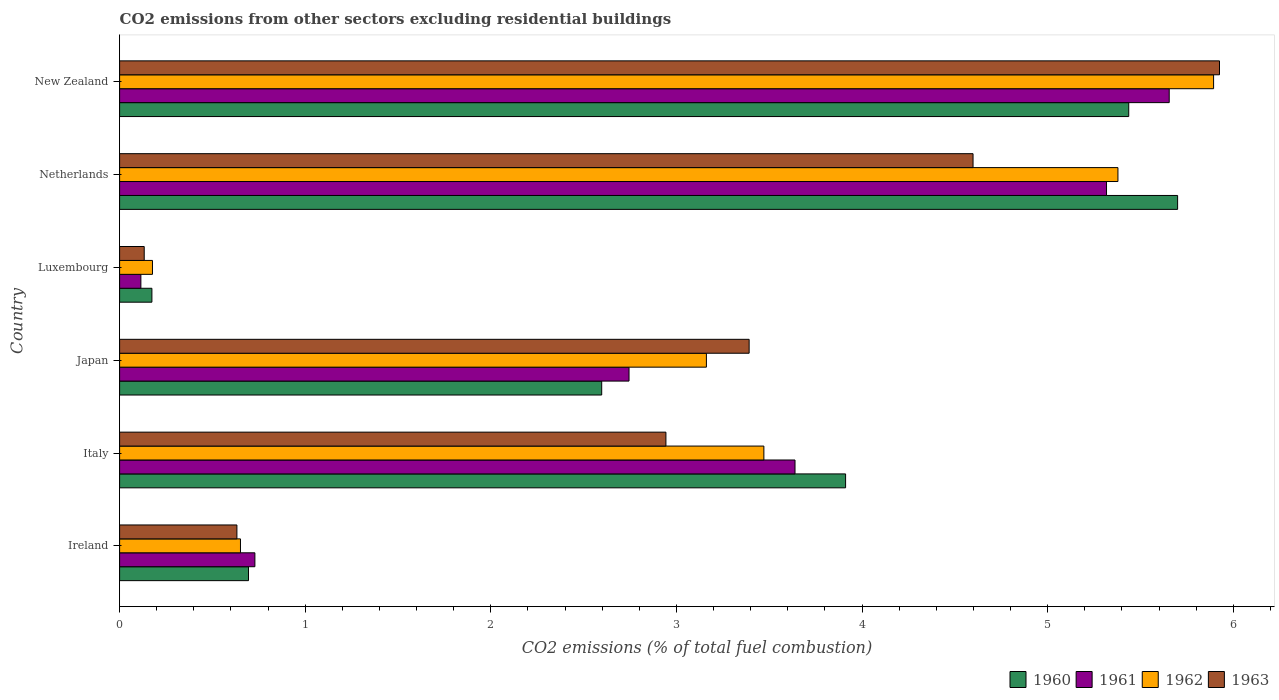How many different coloured bars are there?
Ensure brevity in your answer.  4. How many groups of bars are there?
Keep it short and to the point. 6. Are the number of bars per tick equal to the number of legend labels?
Provide a short and direct response. Yes. How many bars are there on the 1st tick from the top?
Ensure brevity in your answer.  4. What is the label of the 2nd group of bars from the top?
Keep it short and to the point. Netherlands. In how many cases, is the number of bars for a given country not equal to the number of legend labels?
Ensure brevity in your answer.  0. What is the total CO2 emitted in 1962 in Ireland?
Your answer should be compact. 0.65. Across all countries, what is the maximum total CO2 emitted in 1961?
Your response must be concise. 5.66. Across all countries, what is the minimum total CO2 emitted in 1960?
Offer a terse response. 0.17. In which country was the total CO2 emitted in 1960 minimum?
Your answer should be very brief. Luxembourg. What is the total total CO2 emitted in 1963 in the graph?
Offer a terse response. 17.62. What is the difference between the total CO2 emitted in 1962 in Italy and that in New Zealand?
Your response must be concise. -2.42. What is the difference between the total CO2 emitted in 1961 in Ireland and the total CO2 emitted in 1960 in New Zealand?
Your answer should be compact. -4.71. What is the average total CO2 emitted in 1963 per country?
Offer a terse response. 2.94. What is the difference between the total CO2 emitted in 1963 and total CO2 emitted in 1961 in Italy?
Provide a short and direct response. -0.7. In how many countries, is the total CO2 emitted in 1963 greater than 2.4 ?
Ensure brevity in your answer.  4. What is the ratio of the total CO2 emitted in 1961 in Japan to that in New Zealand?
Ensure brevity in your answer.  0.49. Is the total CO2 emitted in 1962 in Ireland less than that in Luxembourg?
Your response must be concise. No. Is the difference between the total CO2 emitted in 1963 in Italy and Luxembourg greater than the difference between the total CO2 emitted in 1961 in Italy and Luxembourg?
Your response must be concise. No. What is the difference between the highest and the second highest total CO2 emitted in 1961?
Your answer should be compact. 0.34. What is the difference between the highest and the lowest total CO2 emitted in 1962?
Your response must be concise. 5.72. Is it the case that in every country, the sum of the total CO2 emitted in 1962 and total CO2 emitted in 1961 is greater than the sum of total CO2 emitted in 1960 and total CO2 emitted in 1963?
Offer a terse response. No. What does the 2nd bar from the top in Ireland represents?
Offer a very short reply. 1962. Is it the case that in every country, the sum of the total CO2 emitted in 1960 and total CO2 emitted in 1962 is greater than the total CO2 emitted in 1963?
Your response must be concise. Yes. Are all the bars in the graph horizontal?
Ensure brevity in your answer.  Yes. What is the difference between two consecutive major ticks on the X-axis?
Provide a succinct answer. 1. Are the values on the major ticks of X-axis written in scientific E-notation?
Your answer should be compact. No. Does the graph contain grids?
Make the answer very short. No. Where does the legend appear in the graph?
Provide a short and direct response. Bottom right. How many legend labels are there?
Offer a very short reply. 4. How are the legend labels stacked?
Your answer should be compact. Horizontal. What is the title of the graph?
Offer a very short reply. CO2 emissions from other sectors excluding residential buildings. Does "1980" appear as one of the legend labels in the graph?
Make the answer very short. No. What is the label or title of the X-axis?
Offer a very short reply. CO2 emissions (% of total fuel combustion). What is the label or title of the Y-axis?
Offer a very short reply. Country. What is the CO2 emissions (% of total fuel combustion) of 1960 in Ireland?
Make the answer very short. 0.69. What is the CO2 emissions (% of total fuel combustion) in 1961 in Ireland?
Your answer should be very brief. 0.73. What is the CO2 emissions (% of total fuel combustion) in 1962 in Ireland?
Offer a terse response. 0.65. What is the CO2 emissions (% of total fuel combustion) of 1963 in Ireland?
Give a very brief answer. 0.63. What is the CO2 emissions (% of total fuel combustion) of 1960 in Italy?
Your response must be concise. 3.91. What is the CO2 emissions (% of total fuel combustion) in 1961 in Italy?
Your answer should be compact. 3.64. What is the CO2 emissions (% of total fuel combustion) in 1962 in Italy?
Your answer should be very brief. 3.47. What is the CO2 emissions (% of total fuel combustion) of 1963 in Italy?
Give a very brief answer. 2.94. What is the CO2 emissions (% of total fuel combustion) in 1960 in Japan?
Provide a short and direct response. 2.6. What is the CO2 emissions (% of total fuel combustion) of 1961 in Japan?
Your response must be concise. 2.74. What is the CO2 emissions (% of total fuel combustion) in 1962 in Japan?
Your answer should be very brief. 3.16. What is the CO2 emissions (% of total fuel combustion) in 1963 in Japan?
Ensure brevity in your answer.  3.39. What is the CO2 emissions (% of total fuel combustion) of 1960 in Luxembourg?
Make the answer very short. 0.17. What is the CO2 emissions (% of total fuel combustion) of 1961 in Luxembourg?
Your answer should be compact. 0.11. What is the CO2 emissions (% of total fuel combustion) of 1962 in Luxembourg?
Your response must be concise. 0.18. What is the CO2 emissions (% of total fuel combustion) in 1963 in Luxembourg?
Provide a short and direct response. 0.13. What is the CO2 emissions (% of total fuel combustion) in 1960 in Netherlands?
Your answer should be compact. 5.7. What is the CO2 emissions (% of total fuel combustion) of 1961 in Netherlands?
Make the answer very short. 5.32. What is the CO2 emissions (% of total fuel combustion) of 1962 in Netherlands?
Offer a very short reply. 5.38. What is the CO2 emissions (% of total fuel combustion) in 1963 in Netherlands?
Offer a terse response. 4.6. What is the CO2 emissions (% of total fuel combustion) in 1960 in New Zealand?
Offer a very short reply. 5.44. What is the CO2 emissions (% of total fuel combustion) in 1961 in New Zealand?
Give a very brief answer. 5.66. What is the CO2 emissions (% of total fuel combustion) of 1962 in New Zealand?
Offer a terse response. 5.89. What is the CO2 emissions (% of total fuel combustion) of 1963 in New Zealand?
Your response must be concise. 5.93. Across all countries, what is the maximum CO2 emissions (% of total fuel combustion) in 1960?
Ensure brevity in your answer.  5.7. Across all countries, what is the maximum CO2 emissions (% of total fuel combustion) in 1961?
Provide a succinct answer. 5.66. Across all countries, what is the maximum CO2 emissions (% of total fuel combustion) of 1962?
Offer a terse response. 5.89. Across all countries, what is the maximum CO2 emissions (% of total fuel combustion) in 1963?
Provide a succinct answer. 5.93. Across all countries, what is the minimum CO2 emissions (% of total fuel combustion) in 1960?
Your answer should be very brief. 0.17. Across all countries, what is the minimum CO2 emissions (% of total fuel combustion) in 1961?
Provide a short and direct response. 0.11. Across all countries, what is the minimum CO2 emissions (% of total fuel combustion) of 1962?
Provide a short and direct response. 0.18. Across all countries, what is the minimum CO2 emissions (% of total fuel combustion) of 1963?
Your answer should be very brief. 0.13. What is the total CO2 emissions (% of total fuel combustion) of 1960 in the graph?
Offer a terse response. 18.51. What is the total CO2 emissions (% of total fuel combustion) of 1961 in the graph?
Provide a succinct answer. 18.2. What is the total CO2 emissions (% of total fuel combustion) in 1962 in the graph?
Offer a very short reply. 18.73. What is the total CO2 emissions (% of total fuel combustion) of 1963 in the graph?
Your answer should be very brief. 17.62. What is the difference between the CO2 emissions (% of total fuel combustion) of 1960 in Ireland and that in Italy?
Your answer should be compact. -3.22. What is the difference between the CO2 emissions (% of total fuel combustion) of 1961 in Ireland and that in Italy?
Your response must be concise. -2.91. What is the difference between the CO2 emissions (% of total fuel combustion) in 1962 in Ireland and that in Italy?
Provide a succinct answer. -2.82. What is the difference between the CO2 emissions (% of total fuel combustion) in 1963 in Ireland and that in Italy?
Offer a very short reply. -2.31. What is the difference between the CO2 emissions (% of total fuel combustion) of 1960 in Ireland and that in Japan?
Make the answer very short. -1.9. What is the difference between the CO2 emissions (% of total fuel combustion) in 1961 in Ireland and that in Japan?
Provide a short and direct response. -2.02. What is the difference between the CO2 emissions (% of total fuel combustion) of 1962 in Ireland and that in Japan?
Keep it short and to the point. -2.51. What is the difference between the CO2 emissions (% of total fuel combustion) of 1963 in Ireland and that in Japan?
Keep it short and to the point. -2.76. What is the difference between the CO2 emissions (% of total fuel combustion) in 1960 in Ireland and that in Luxembourg?
Provide a short and direct response. 0.52. What is the difference between the CO2 emissions (% of total fuel combustion) in 1961 in Ireland and that in Luxembourg?
Offer a terse response. 0.61. What is the difference between the CO2 emissions (% of total fuel combustion) of 1962 in Ireland and that in Luxembourg?
Your answer should be very brief. 0.47. What is the difference between the CO2 emissions (% of total fuel combustion) in 1963 in Ireland and that in Luxembourg?
Provide a succinct answer. 0.5. What is the difference between the CO2 emissions (% of total fuel combustion) in 1960 in Ireland and that in Netherlands?
Your answer should be very brief. -5.01. What is the difference between the CO2 emissions (% of total fuel combustion) of 1961 in Ireland and that in Netherlands?
Your answer should be compact. -4.59. What is the difference between the CO2 emissions (% of total fuel combustion) in 1962 in Ireland and that in Netherlands?
Offer a terse response. -4.73. What is the difference between the CO2 emissions (% of total fuel combustion) in 1963 in Ireland and that in Netherlands?
Your response must be concise. -3.97. What is the difference between the CO2 emissions (% of total fuel combustion) in 1960 in Ireland and that in New Zealand?
Keep it short and to the point. -4.74. What is the difference between the CO2 emissions (% of total fuel combustion) of 1961 in Ireland and that in New Zealand?
Make the answer very short. -4.93. What is the difference between the CO2 emissions (% of total fuel combustion) of 1962 in Ireland and that in New Zealand?
Offer a very short reply. -5.24. What is the difference between the CO2 emissions (% of total fuel combustion) of 1963 in Ireland and that in New Zealand?
Provide a succinct answer. -5.29. What is the difference between the CO2 emissions (% of total fuel combustion) of 1960 in Italy and that in Japan?
Make the answer very short. 1.31. What is the difference between the CO2 emissions (% of total fuel combustion) in 1961 in Italy and that in Japan?
Provide a succinct answer. 0.89. What is the difference between the CO2 emissions (% of total fuel combustion) of 1962 in Italy and that in Japan?
Offer a very short reply. 0.31. What is the difference between the CO2 emissions (% of total fuel combustion) in 1963 in Italy and that in Japan?
Provide a short and direct response. -0.45. What is the difference between the CO2 emissions (% of total fuel combustion) in 1960 in Italy and that in Luxembourg?
Your answer should be very brief. 3.74. What is the difference between the CO2 emissions (% of total fuel combustion) in 1961 in Italy and that in Luxembourg?
Keep it short and to the point. 3.52. What is the difference between the CO2 emissions (% of total fuel combustion) in 1962 in Italy and that in Luxembourg?
Offer a very short reply. 3.29. What is the difference between the CO2 emissions (% of total fuel combustion) of 1963 in Italy and that in Luxembourg?
Ensure brevity in your answer.  2.81. What is the difference between the CO2 emissions (% of total fuel combustion) in 1960 in Italy and that in Netherlands?
Give a very brief answer. -1.79. What is the difference between the CO2 emissions (% of total fuel combustion) of 1961 in Italy and that in Netherlands?
Provide a succinct answer. -1.68. What is the difference between the CO2 emissions (% of total fuel combustion) in 1962 in Italy and that in Netherlands?
Give a very brief answer. -1.91. What is the difference between the CO2 emissions (% of total fuel combustion) in 1963 in Italy and that in Netherlands?
Your response must be concise. -1.65. What is the difference between the CO2 emissions (% of total fuel combustion) in 1960 in Italy and that in New Zealand?
Provide a short and direct response. -1.53. What is the difference between the CO2 emissions (% of total fuel combustion) of 1961 in Italy and that in New Zealand?
Your answer should be very brief. -2.02. What is the difference between the CO2 emissions (% of total fuel combustion) of 1962 in Italy and that in New Zealand?
Your answer should be compact. -2.42. What is the difference between the CO2 emissions (% of total fuel combustion) in 1963 in Italy and that in New Zealand?
Make the answer very short. -2.98. What is the difference between the CO2 emissions (% of total fuel combustion) of 1960 in Japan and that in Luxembourg?
Provide a succinct answer. 2.42. What is the difference between the CO2 emissions (% of total fuel combustion) in 1961 in Japan and that in Luxembourg?
Offer a terse response. 2.63. What is the difference between the CO2 emissions (% of total fuel combustion) in 1962 in Japan and that in Luxembourg?
Offer a very short reply. 2.98. What is the difference between the CO2 emissions (% of total fuel combustion) of 1963 in Japan and that in Luxembourg?
Give a very brief answer. 3.26. What is the difference between the CO2 emissions (% of total fuel combustion) of 1960 in Japan and that in Netherlands?
Keep it short and to the point. -3.1. What is the difference between the CO2 emissions (% of total fuel combustion) in 1961 in Japan and that in Netherlands?
Offer a terse response. -2.57. What is the difference between the CO2 emissions (% of total fuel combustion) of 1962 in Japan and that in Netherlands?
Provide a succinct answer. -2.22. What is the difference between the CO2 emissions (% of total fuel combustion) of 1963 in Japan and that in Netherlands?
Offer a very short reply. -1.21. What is the difference between the CO2 emissions (% of total fuel combustion) in 1960 in Japan and that in New Zealand?
Keep it short and to the point. -2.84. What is the difference between the CO2 emissions (% of total fuel combustion) of 1961 in Japan and that in New Zealand?
Provide a succinct answer. -2.91. What is the difference between the CO2 emissions (% of total fuel combustion) in 1962 in Japan and that in New Zealand?
Ensure brevity in your answer.  -2.73. What is the difference between the CO2 emissions (% of total fuel combustion) of 1963 in Japan and that in New Zealand?
Your response must be concise. -2.53. What is the difference between the CO2 emissions (% of total fuel combustion) of 1960 in Luxembourg and that in Netherlands?
Offer a very short reply. -5.53. What is the difference between the CO2 emissions (% of total fuel combustion) in 1961 in Luxembourg and that in Netherlands?
Your answer should be compact. -5.2. What is the difference between the CO2 emissions (% of total fuel combustion) in 1962 in Luxembourg and that in Netherlands?
Your answer should be very brief. -5.2. What is the difference between the CO2 emissions (% of total fuel combustion) of 1963 in Luxembourg and that in Netherlands?
Give a very brief answer. -4.47. What is the difference between the CO2 emissions (% of total fuel combustion) of 1960 in Luxembourg and that in New Zealand?
Your answer should be very brief. -5.26. What is the difference between the CO2 emissions (% of total fuel combustion) of 1961 in Luxembourg and that in New Zealand?
Ensure brevity in your answer.  -5.54. What is the difference between the CO2 emissions (% of total fuel combustion) of 1962 in Luxembourg and that in New Zealand?
Keep it short and to the point. -5.72. What is the difference between the CO2 emissions (% of total fuel combustion) in 1963 in Luxembourg and that in New Zealand?
Provide a succinct answer. -5.79. What is the difference between the CO2 emissions (% of total fuel combustion) of 1960 in Netherlands and that in New Zealand?
Provide a short and direct response. 0.26. What is the difference between the CO2 emissions (% of total fuel combustion) of 1961 in Netherlands and that in New Zealand?
Your answer should be very brief. -0.34. What is the difference between the CO2 emissions (% of total fuel combustion) of 1962 in Netherlands and that in New Zealand?
Ensure brevity in your answer.  -0.52. What is the difference between the CO2 emissions (% of total fuel combustion) in 1963 in Netherlands and that in New Zealand?
Offer a very short reply. -1.33. What is the difference between the CO2 emissions (% of total fuel combustion) of 1960 in Ireland and the CO2 emissions (% of total fuel combustion) of 1961 in Italy?
Give a very brief answer. -2.94. What is the difference between the CO2 emissions (% of total fuel combustion) of 1960 in Ireland and the CO2 emissions (% of total fuel combustion) of 1962 in Italy?
Provide a short and direct response. -2.78. What is the difference between the CO2 emissions (% of total fuel combustion) in 1960 in Ireland and the CO2 emissions (% of total fuel combustion) in 1963 in Italy?
Offer a terse response. -2.25. What is the difference between the CO2 emissions (% of total fuel combustion) in 1961 in Ireland and the CO2 emissions (% of total fuel combustion) in 1962 in Italy?
Your answer should be very brief. -2.74. What is the difference between the CO2 emissions (% of total fuel combustion) of 1961 in Ireland and the CO2 emissions (% of total fuel combustion) of 1963 in Italy?
Offer a very short reply. -2.21. What is the difference between the CO2 emissions (% of total fuel combustion) of 1962 in Ireland and the CO2 emissions (% of total fuel combustion) of 1963 in Italy?
Make the answer very short. -2.29. What is the difference between the CO2 emissions (% of total fuel combustion) in 1960 in Ireland and the CO2 emissions (% of total fuel combustion) in 1961 in Japan?
Give a very brief answer. -2.05. What is the difference between the CO2 emissions (% of total fuel combustion) of 1960 in Ireland and the CO2 emissions (% of total fuel combustion) of 1962 in Japan?
Provide a short and direct response. -2.47. What is the difference between the CO2 emissions (% of total fuel combustion) in 1960 in Ireland and the CO2 emissions (% of total fuel combustion) in 1963 in Japan?
Provide a succinct answer. -2.7. What is the difference between the CO2 emissions (% of total fuel combustion) in 1961 in Ireland and the CO2 emissions (% of total fuel combustion) in 1962 in Japan?
Provide a succinct answer. -2.43. What is the difference between the CO2 emissions (% of total fuel combustion) of 1961 in Ireland and the CO2 emissions (% of total fuel combustion) of 1963 in Japan?
Your answer should be very brief. -2.66. What is the difference between the CO2 emissions (% of total fuel combustion) in 1962 in Ireland and the CO2 emissions (% of total fuel combustion) in 1963 in Japan?
Make the answer very short. -2.74. What is the difference between the CO2 emissions (% of total fuel combustion) in 1960 in Ireland and the CO2 emissions (% of total fuel combustion) in 1961 in Luxembourg?
Provide a succinct answer. 0.58. What is the difference between the CO2 emissions (% of total fuel combustion) of 1960 in Ireland and the CO2 emissions (% of total fuel combustion) of 1962 in Luxembourg?
Provide a succinct answer. 0.52. What is the difference between the CO2 emissions (% of total fuel combustion) in 1960 in Ireland and the CO2 emissions (% of total fuel combustion) in 1963 in Luxembourg?
Your answer should be very brief. 0.56. What is the difference between the CO2 emissions (% of total fuel combustion) of 1961 in Ireland and the CO2 emissions (% of total fuel combustion) of 1962 in Luxembourg?
Your answer should be compact. 0.55. What is the difference between the CO2 emissions (% of total fuel combustion) of 1961 in Ireland and the CO2 emissions (% of total fuel combustion) of 1963 in Luxembourg?
Your answer should be very brief. 0.6. What is the difference between the CO2 emissions (% of total fuel combustion) in 1962 in Ireland and the CO2 emissions (% of total fuel combustion) in 1963 in Luxembourg?
Offer a very short reply. 0.52. What is the difference between the CO2 emissions (% of total fuel combustion) in 1960 in Ireland and the CO2 emissions (% of total fuel combustion) in 1961 in Netherlands?
Keep it short and to the point. -4.62. What is the difference between the CO2 emissions (% of total fuel combustion) in 1960 in Ireland and the CO2 emissions (% of total fuel combustion) in 1962 in Netherlands?
Ensure brevity in your answer.  -4.68. What is the difference between the CO2 emissions (% of total fuel combustion) of 1960 in Ireland and the CO2 emissions (% of total fuel combustion) of 1963 in Netherlands?
Your answer should be very brief. -3.9. What is the difference between the CO2 emissions (% of total fuel combustion) of 1961 in Ireland and the CO2 emissions (% of total fuel combustion) of 1962 in Netherlands?
Keep it short and to the point. -4.65. What is the difference between the CO2 emissions (% of total fuel combustion) of 1961 in Ireland and the CO2 emissions (% of total fuel combustion) of 1963 in Netherlands?
Provide a succinct answer. -3.87. What is the difference between the CO2 emissions (% of total fuel combustion) of 1962 in Ireland and the CO2 emissions (% of total fuel combustion) of 1963 in Netherlands?
Offer a very short reply. -3.95. What is the difference between the CO2 emissions (% of total fuel combustion) of 1960 in Ireland and the CO2 emissions (% of total fuel combustion) of 1961 in New Zealand?
Make the answer very short. -4.96. What is the difference between the CO2 emissions (% of total fuel combustion) in 1960 in Ireland and the CO2 emissions (% of total fuel combustion) in 1962 in New Zealand?
Give a very brief answer. -5.2. What is the difference between the CO2 emissions (% of total fuel combustion) of 1960 in Ireland and the CO2 emissions (% of total fuel combustion) of 1963 in New Zealand?
Ensure brevity in your answer.  -5.23. What is the difference between the CO2 emissions (% of total fuel combustion) in 1961 in Ireland and the CO2 emissions (% of total fuel combustion) in 1962 in New Zealand?
Offer a terse response. -5.17. What is the difference between the CO2 emissions (% of total fuel combustion) in 1961 in Ireland and the CO2 emissions (% of total fuel combustion) in 1963 in New Zealand?
Offer a very short reply. -5.2. What is the difference between the CO2 emissions (% of total fuel combustion) in 1962 in Ireland and the CO2 emissions (% of total fuel combustion) in 1963 in New Zealand?
Your response must be concise. -5.27. What is the difference between the CO2 emissions (% of total fuel combustion) of 1960 in Italy and the CO2 emissions (% of total fuel combustion) of 1961 in Japan?
Keep it short and to the point. 1.17. What is the difference between the CO2 emissions (% of total fuel combustion) in 1960 in Italy and the CO2 emissions (% of total fuel combustion) in 1962 in Japan?
Offer a very short reply. 0.75. What is the difference between the CO2 emissions (% of total fuel combustion) of 1960 in Italy and the CO2 emissions (% of total fuel combustion) of 1963 in Japan?
Provide a succinct answer. 0.52. What is the difference between the CO2 emissions (% of total fuel combustion) in 1961 in Italy and the CO2 emissions (% of total fuel combustion) in 1962 in Japan?
Ensure brevity in your answer.  0.48. What is the difference between the CO2 emissions (% of total fuel combustion) in 1961 in Italy and the CO2 emissions (% of total fuel combustion) in 1963 in Japan?
Offer a very short reply. 0.25. What is the difference between the CO2 emissions (% of total fuel combustion) in 1962 in Italy and the CO2 emissions (% of total fuel combustion) in 1963 in Japan?
Your answer should be very brief. 0.08. What is the difference between the CO2 emissions (% of total fuel combustion) in 1960 in Italy and the CO2 emissions (% of total fuel combustion) in 1961 in Luxembourg?
Offer a very short reply. 3.8. What is the difference between the CO2 emissions (% of total fuel combustion) in 1960 in Italy and the CO2 emissions (% of total fuel combustion) in 1962 in Luxembourg?
Offer a terse response. 3.73. What is the difference between the CO2 emissions (% of total fuel combustion) in 1960 in Italy and the CO2 emissions (% of total fuel combustion) in 1963 in Luxembourg?
Provide a succinct answer. 3.78. What is the difference between the CO2 emissions (% of total fuel combustion) of 1961 in Italy and the CO2 emissions (% of total fuel combustion) of 1962 in Luxembourg?
Ensure brevity in your answer.  3.46. What is the difference between the CO2 emissions (% of total fuel combustion) in 1961 in Italy and the CO2 emissions (% of total fuel combustion) in 1963 in Luxembourg?
Provide a short and direct response. 3.51. What is the difference between the CO2 emissions (% of total fuel combustion) of 1962 in Italy and the CO2 emissions (% of total fuel combustion) of 1963 in Luxembourg?
Give a very brief answer. 3.34. What is the difference between the CO2 emissions (% of total fuel combustion) in 1960 in Italy and the CO2 emissions (% of total fuel combustion) in 1961 in Netherlands?
Make the answer very short. -1.41. What is the difference between the CO2 emissions (% of total fuel combustion) of 1960 in Italy and the CO2 emissions (% of total fuel combustion) of 1962 in Netherlands?
Make the answer very short. -1.47. What is the difference between the CO2 emissions (% of total fuel combustion) of 1960 in Italy and the CO2 emissions (% of total fuel combustion) of 1963 in Netherlands?
Your response must be concise. -0.69. What is the difference between the CO2 emissions (% of total fuel combustion) of 1961 in Italy and the CO2 emissions (% of total fuel combustion) of 1962 in Netherlands?
Give a very brief answer. -1.74. What is the difference between the CO2 emissions (% of total fuel combustion) in 1961 in Italy and the CO2 emissions (% of total fuel combustion) in 1963 in Netherlands?
Your answer should be compact. -0.96. What is the difference between the CO2 emissions (% of total fuel combustion) in 1962 in Italy and the CO2 emissions (% of total fuel combustion) in 1963 in Netherlands?
Provide a succinct answer. -1.13. What is the difference between the CO2 emissions (% of total fuel combustion) in 1960 in Italy and the CO2 emissions (% of total fuel combustion) in 1961 in New Zealand?
Offer a terse response. -1.74. What is the difference between the CO2 emissions (% of total fuel combustion) in 1960 in Italy and the CO2 emissions (% of total fuel combustion) in 1962 in New Zealand?
Make the answer very short. -1.98. What is the difference between the CO2 emissions (% of total fuel combustion) of 1960 in Italy and the CO2 emissions (% of total fuel combustion) of 1963 in New Zealand?
Provide a succinct answer. -2.01. What is the difference between the CO2 emissions (% of total fuel combustion) of 1961 in Italy and the CO2 emissions (% of total fuel combustion) of 1962 in New Zealand?
Make the answer very short. -2.26. What is the difference between the CO2 emissions (% of total fuel combustion) in 1961 in Italy and the CO2 emissions (% of total fuel combustion) in 1963 in New Zealand?
Provide a short and direct response. -2.29. What is the difference between the CO2 emissions (% of total fuel combustion) in 1962 in Italy and the CO2 emissions (% of total fuel combustion) in 1963 in New Zealand?
Your response must be concise. -2.45. What is the difference between the CO2 emissions (% of total fuel combustion) in 1960 in Japan and the CO2 emissions (% of total fuel combustion) in 1961 in Luxembourg?
Provide a succinct answer. 2.48. What is the difference between the CO2 emissions (% of total fuel combustion) in 1960 in Japan and the CO2 emissions (% of total fuel combustion) in 1962 in Luxembourg?
Ensure brevity in your answer.  2.42. What is the difference between the CO2 emissions (% of total fuel combustion) in 1960 in Japan and the CO2 emissions (% of total fuel combustion) in 1963 in Luxembourg?
Offer a terse response. 2.46. What is the difference between the CO2 emissions (% of total fuel combustion) in 1961 in Japan and the CO2 emissions (% of total fuel combustion) in 1962 in Luxembourg?
Offer a very short reply. 2.57. What is the difference between the CO2 emissions (% of total fuel combustion) in 1961 in Japan and the CO2 emissions (% of total fuel combustion) in 1963 in Luxembourg?
Keep it short and to the point. 2.61. What is the difference between the CO2 emissions (% of total fuel combustion) of 1962 in Japan and the CO2 emissions (% of total fuel combustion) of 1963 in Luxembourg?
Give a very brief answer. 3.03. What is the difference between the CO2 emissions (% of total fuel combustion) of 1960 in Japan and the CO2 emissions (% of total fuel combustion) of 1961 in Netherlands?
Keep it short and to the point. -2.72. What is the difference between the CO2 emissions (% of total fuel combustion) of 1960 in Japan and the CO2 emissions (% of total fuel combustion) of 1962 in Netherlands?
Offer a terse response. -2.78. What is the difference between the CO2 emissions (% of total fuel combustion) in 1960 in Japan and the CO2 emissions (% of total fuel combustion) in 1963 in Netherlands?
Your answer should be very brief. -2. What is the difference between the CO2 emissions (% of total fuel combustion) in 1961 in Japan and the CO2 emissions (% of total fuel combustion) in 1962 in Netherlands?
Provide a succinct answer. -2.63. What is the difference between the CO2 emissions (% of total fuel combustion) in 1961 in Japan and the CO2 emissions (% of total fuel combustion) in 1963 in Netherlands?
Provide a succinct answer. -1.85. What is the difference between the CO2 emissions (% of total fuel combustion) in 1962 in Japan and the CO2 emissions (% of total fuel combustion) in 1963 in Netherlands?
Your response must be concise. -1.44. What is the difference between the CO2 emissions (% of total fuel combustion) in 1960 in Japan and the CO2 emissions (% of total fuel combustion) in 1961 in New Zealand?
Make the answer very short. -3.06. What is the difference between the CO2 emissions (% of total fuel combustion) of 1960 in Japan and the CO2 emissions (% of total fuel combustion) of 1962 in New Zealand?
Make the answer very short. -3.3. What is the difference between the CO2 emissions (% of total fuel combustion) of 1960 in Japan and the CO2 emissions (% of total fuel combustion) of 1963 in New Zealand?
Ensure brevity in your answer.  -3.33. What is the difference between the CO2 emissions (% of total fuel combustion) in 1961 in Japan and the CO2 emissions (% of total fuel combustion) in 1962 in New Zealand?
Offer a terse response. -3.15. What is the difference between the CO2 emissions (% of total fuel combustion) of 1961 in Japan and the CO2 emissions (% of total fuel combustion) of 1963 in New Zealand?
Offer a very short reply. -3.18. What is the difference between the CO2 emissions (% of total fuel combustion) in 1962 in Japan and the CO2 emissions (% of total fuel combustion) in 1963 in New Zealand?
Offer a terse response. -2.76. What is the difference between the CO2 emissions (% of total fuel combustion) in 1960 in Luxembourg and the CO2 emissions (% of total fuel combustion) in 1961 in Netherlands?
Your response must be concise. -5.14. What is the difference between the CO2 emissions (% of total fuel combustion) in 1960 in Luxembourg and the CO2 emissions (% of total fuel combustion) in 1962 in Netherlands?
Provide a short and direct response. -5.2. What is the difference between the CO2 emissions (% of total fuel combustion) of 1960 in Luxembourg and the CO2 emissions (% of total fuel combustion) of 1963 in Netherlands?
Make the answer very short. -4.42. What is the difference between the CO2 emissions (% of total fuel combustion) of 1961 in Luxembourg and the CO2 emissions (% of total fuel combustion) of 1962 in Netherlands?
Give a very brief answer. -5.26. What is the difference between the CO2 emissions (% of total fuel combustion) in 1961 in Luxembourg and the CO2 emissions (% of total fuel combustion) in 1963 in Netherlands?
Provide a succinct answer. -4.48. What is the difference between the CO2 emissions (% of total fuel combustion) in 1962 in Luxembourg and the CO2 emissions (% of total fuel combustion) in 1963 in Netherlands?
Offer a terse response. -4.42. What is the difference between the CO2 emissions (% of total fuel combustion) of 1960 in Luxembourg and the CO2 emissions (% of total fuel combustion) of 1961 in New Zealand?
Offer a terse response. -5.48. What is the difference between the CO2 emissions (% of total fuel combustion) in 1960 in Luxembourg and the CO2 emissions (% of total fuel combustion) in 1962 in New Zealand?
Your response must be concise. -5.72. What is the difference between the CO2 emissions (% of total fuel combustion) of 1960 in Luxembourg and the CO2 emissions (% of total fuel combustion) of 1963 in New Zealand?
Your answer should be compact. -5.75. What is the difference between the CO2 emissions (% of total fuel combustion) of 1961 in Luxembourg and the CO2 emissions (% of total fuel combustion) of 1962 in New Zealand?
Keep it short and to the point. -5.78. What is the difference between the CO2 emissions (% of total fuel combustion) of 1961 in Luxembourg and the CO2 emissions (% of total fuel combustion) of 1963 in New Zealand?
Ensure brevity in your answer.  -5.81. What is the difference between the CO2 emissions (% of total fuel combustion) in 1962 in Luxembourg and the CO2 emissions (% of total fuel combustion) in 1963 in New Zealand?
Your answer should be compact. -5.75. What is the difference between the CO2 emissions (% of total fuel combustion) of 1960 in Netherlands and the CO2 emissions (% of total fuel combustion) of 1961 in New Zealand?
Ensure brevity in your answer.  0.05. What is the difference between the CO2 emissions (% of total fuel combustion) in 1960 in Netherlands and the CO2 emissions (% of total fuel combustion) in 1962 in New Zealand?
Keep it short and to the point. -0.19. What is the difference between the CO2 emissions (% of total fuel combustion) of 1960 in Netherlands and the CO2 emissions (% of total fuel combustion) of 1963 in New Zealand?
Provide a short and direct response. -0.23. What is the difference between the CO2 emissions (% of total fuel combustion) in 1961 in Netherlands and the CO2 emissions (% of total fuel combustion) in 1962 in New Zealand?
Your response must be concise. -0.58. What is the difference between the CO2 emissions (% of total fuel combustion) in 1961 in Netherlands and the CO2 emissions (% of total fuel combustion) in 1963 in New Zealand?
Your answer should be compact. -0.61. What is the difference between the CO2 emissions (% of total fuel combustion) in 1962 in Netherlands and the CO2 emissions (% of total fuel combustion) in 1963 in New Zealand?
Provide a short and direct response. -0.55. What is the average CO2 emissions (% of total fuel combustion) of 1960 per country?
Offer a terse response. 3.09. What is the average CO2 emissions (% of total fuel combustion) of 1961 per country?
Offer a very short reply. 3.03. What is the average CO2 emissions (% of total fuel combustion) of 1962 per country?
Provide a short and direct response. 3.12. What is the average CO2 emissions (% of total fuel combustion) in 1963 per country?
Provide a short and direct response. 2.94. What is the difference between the CO2 emissions (% of total fuel combustion) in 1960 and CO2 emissions (% of total fuel combustion) in 1961 in Ireland?
Provide a succinct answer. -0.03. What is the difference between the CO2 emissions (% of total fuel combustion) in 1960 and CO2 emissions (% of total fuel combustion) in 1962 in Ireland?
Provide a short and direct response. 0.04. What is the difference between the CO2 emissions (% of total fuel combustion) in 1960 and CO2 emissions (% of total fuel combustion) in 1963 in Ireland?
Ensure brevity in your answer.  0.06. What is the difference between the CO2 emissions (% of total fuel combustion) in 1961 and CO2 emissions (% of total fuel combustion) in 1962 in Ireland?
Offer a terse response. 0.08. What is the difference between the CO2 emissions (% of total fuel combustion) in 1961 and CO2 emissions (% of total fuel combustion) in 1963 in Ireland?
Your answer should be very brief. 0.1. What is the difference between the CO2 emissions (% of total fuel combustion) of 1962 and CO2 emissions (% of total fuel combustion) of 1963 in Ireland?
Make the answer very short. 0.02. What is the difference between the CO2 emissions (% of total fuel combustion) in 1960 and CO2 emissions (% of total fuel combustion) in 1961 in Italy?
Ensure brevity in your answer.  0.27. What is the difference between the CO2 emissions (% of total fuel combustion) in 1960 and CO2 emissions (% of total fuel combustion) in 1962 in Italy?
Provide a succinct answer. 0.44. What is the difference between the CO2 emissions (% of total fuel combustion) of 1961 and CO2 emissions (% of total fuel combustion) of 1962 in Italy?
Give a very brief answer. 0.17. What is the difference between the CO2 emissions (% of total fuel combustion) of 1961 and CO2 emissions (% of total fuel combustion) of 1963 in Italy?
Make the answer very short. 0.7. What is the difference between the CO2 emissions (% of total fuel combustion) in 1962 and CO2 emissions (% of total fuel combustion) in 1963 in Italy?
Provide a succinct answer. 0.53. What is the difference between the CO2 emissions (% of total fuel combustion) of 1960 and CO2 emissions (% of total fuel combustion) of 1961 in Japan?
Offer a very short reply. -0.15. What is the difference between the CO2 emissions (% of total fuel combustion) in 1960 and CO2 emissions (% of total fuel combustion) in 1962 in Japan?
Provide a succinct answer. -0.56. What is the difference between the CO2 emissions (% of total fuel combustion) of 1960 and CO2 emissions (% of total fuel combustion) of 1963 in Japan?
Provide a short and direct response. -0.79. What is the difference between the CO2 emissions (% of total fuel combustion) of 1961 and CO2 emissions (% of total fuel combustion) of 1962 in Japan?
Keep it short and to the point. -0.42. What is the difference between the CO2 emissions (% of total fuel combustion) of 1961 and CO2 emissions (% of total fuel combustion) of 1963 in Japan?
Your answer should be very brief. -0.65. What is the difference between the CO2 emissions (% of total fuel combustion) of 1962 and CO2 emissions (% of total fuel combustion) of 1963 in Japan?
Make the answer very short. -0.23. What is the difference between the CO2 emissions (% of total fuel combustion) of 1960 and CO2 emissions (% of total fuel combustion) of 1961 in Luxembourg?
Give a very brief answer. 0.06. What is the difference between the CO2 emissions (% of total fuel combustion) in 1960 and CO2 emissions (% of total fuel combustion) in 1962 in Luxembourg?
Your answer should be very brief. -0. What is the difference between the CO2 emissions (% of total fuel combustion) of 1960 and CO2 emissions (% of total fuel combustion) of 1963 in Luxembourg?
Make the answer very short. 0.04. What is the difference between the CO2 emissions (% of total fuel combustion) in 1961 and CO2 emissions (% of total fuel combustion) in 1962 in Luxembourg?
Your response must be concise. -0.06. What is the difference between the CO2 emissions (% of total fuel combustion) of 1961 and CO2 emissions (% of total fuel combustion) of 1963 in Luxembourg?
Give a very brief answer. -0.02. What is the difference between the CO2 emissions (% of total fuel combustion) in 1962 and CO2 emissions (% of total fuel combustion) in 1963 in Luxembourg?
Your response must be concise. 0.04. What is the difference between the CO2 emissions (% of total fuel combustion) of 1960 and CO2 emissions (% of total fuel combustion) of 1961 in Netherlands?
Keep it short and to the point. 0.38. What is the difference between the CO2 emissions (% of total fuel combustion) in 1960 and CO2 emissions (% of total fuel combustion) in 1962 in Netherlands?
Provide a short and direct response. 0.32. What is the difference between the CO2 emissions (% of total fuel combustion) of 1960 and CO2 emissions (% of total fuel combustion) of 1963 in Netherlands?
Offer a terse response. 1.1. What is the difference between the CO2 emissions (% of total fuel combustion) of 1961 and CO2 emissions (% of total fuel combustion) of 1962 in Netherlands?
Your response must be concise. -0.06. What is the difference between the CO2 emissions (% of total fuel combustion) of 1961 and CO2 emissions (% of total fuel combustion) of 1963 in Netherlands?
Provide a short and direct response. 0.72. What is the difference between the CO2 emissions (% of total fuel combustion) in 1962 and CO2 emissions (% of total fuel combustion) in 1963 in Netherlands?
Provide a succinct answer. 0.78. What is the difference between the CO2 emissions (% of total fuel combustion) of 1960 and CO2 emissions (% of total fuel combustion) of 1961 in New Zealand?
Give a very brief answer. -0.22. What is the difference between the CO2 emissions (% of total fuel combustion) of 1960 and CO2 emissions (% of total fuel combustion) of 1962 in New Zealand?
Provide a succinct answer. -0.46. What is the difference between the CO2 emissions (% of total fuel combustion) of 1960 and CO2 emissions (% of total fuel combustion) of 1963 in New Zealand?
Your answer should be very brief. -0.49. What is the difference between the CO2 emissions (% of total fuel combustion) of 1961 and CO2 emissions (% of total fuel combustion) of 1962 in New Zealand?
Your answer should be compact. -0.24. What is the difference between the CO2 emissions (% of total fuel combustion) in 1961 and CO2 emissions (% of total fuel combustion) in 1963 in New Zealand?
Your answer should be very brief. -0.27. What is the difference between the CO2 emissions (% of total fuel combustion) of 1962 and CO2 emissions (% of total fuel combustion) of 1963 in New Zealand?
Make the answer very short. -0.03. What is the ratio of the CO2 emissions (% of total fuel combustion) of 1960 in Ireland to that in Italy?
Keep it short and to the point. 0.18. What is the ratio of the CO2 emissions (% of total fuel combustion) in 1961 in Ireland to that in Italy?
Your answer should be very brief. 0.2. What is the ratio of the CO2 emissions (% of total fuel combustion) in 1962 in Ireland to that in Italy?
Ensure brevity in your answer.  0.19. What is the ratio of the CO2 emissions (% of total fuel combustion) of 1963 in Ireland to that in Italy?
Provide a succinct answer. 0.21. What is the ratio of the CO2 emissions (% of total fuel combustion) in 1960 in Ireland to that in Japan?
Your response must be concise. 0.27. What is the ratio of the CO2 emissions (% of total fuel combustion) in 1961 in Ireland to that in Japan?
Provide a short and direct response. 0.27. What is the ratio of the CO2 emissions (% of total fuel combustion) of 1962 in Ireland to that in Japan?
Make the answer very short. 0.21. What is the ratio of the CO2 emissions (% of total fuel combustion) in 1963 in Ireland to that in Japan?
Provide a succinct answer. 0.19. What is the ratio of the CO2 emissions (% of total fuel combustion) of 1960 in Ireland to that in Luxembourg?
Your answer should be compact. 3.99. What is the ratio of the CO2 emissions (% of total fuel combustion) in 1961 in Ireland to that in Luxembourg?
Offer a very short reply. 6.36. What is the ratio of the CO2 emissions (% of total fuel combustion) of 1962 in Ireland to that in Luxembourg?
Give a very brief answer. 3.68. What is the ratio of the CO2 emissions (% of total fuel combustion) in 1963 in Ireland to that in Luxembourg?
Your answer should be compact. 4.77. What is the ratio of the CO2 emissions (% of total fuel combustion) in 1960 in Ireland to that in Netherlands?
Offer a very short reply. 0.12. What is the ratio of the CO2 emissions (% of total fuel combustion) in 1961 in Ireland to that in Netherlands?
Make the answer very short. 0.14. What is the ratio of the CO2 emissions (% of total fuel combustion) in 1962 in Ireland to that in Netherlands?
Make the answer very short. 0.12. What is the ratio of the CO2 emissions (% of total fuel combustion) of 1963 in Ireland to that in Netherlands?
Your answer should be very brief. 0.14. What is the ratio of the CO2 emissions (% of total fuel combustion) of 1960 in Ireland to that in New Zealand?
Your response must be concise. 0.13. What is the ratio of the CO2 emissions (% of total fuel combustion) in 1961 in Ireland to that in New Zealand?
Your response must be concise. 0.13. What is the ratio of the CO2 emissions (% of total fuel combustion) of 1962 in Ireland to that in New Zealand?
Your answer should be compact. 0.11. What is the ratio of the CO2 emissions (% of total fuel combustion) in 1963 in Ireland to that in New Zealand?
Give a very brief answer. 0.11. What is the ratio of the CO2 emissions (% of total fuel combustion) of 1960 in Italy to that in Japan?
Offer a very short reply. 1.51. What is the ratio of the CO2 emissions (% of total fuel combustion) in 1961 in Italy to that in Japan?
Your response must be concise. 1.33. What is the ratio of the CO2 emissions (% of total fuel combustion) in 1962 in Italy to that in Japan?
Give a very brief answer. 1.1. What is the ratio of the CO2 emissions (% of total fuel combustion) in 1963 in Italy to that in Japan?
Your answer should be very brief. 0.87. What is the ratio of the CO2 emissions (% of total fuel combustion) of 1960 in Italy to that in Luxembourg?
Your answer should be very brief. 22.48. What is the ratio of the CO2 emissions (% of total fuel combustion) in 1961 in Italy to that in Luxembourg?
Make the answer very short. 31.75. What is the ratio of the CO2 emissions (% of total fuel combustion) in 1962 in Italy to that in Luxembourg?
Offer a very short reply. 19.6. What is the ratio of the CO2 emissions (% of total fuel combustion) in 1963 in Italy to that in Luxembourg?
Ensure brevity in your answer.  22.19. What is the ratio of the CO2 emissions (% of total fuel combustion) of 1960 in Italy to that in Netherlands?
Offer a terse response. 0.69. What is the ratio of the CO2 emissions (% of total fuel combustion) in 1961 in Italy to that in Netherlands?
Give a very brief answer. 0.68. What is the ratio of the CO2 emissions (% of total fuel combustion) of 1962 in Italy to that in Netherlands?
Your answer should be compact. 0.65. What is the ratio of the CO2 emissions (% of total fuel combustion) in 1963 in Italy to that in Netherlands?
Ensure brevity in your answer.  0.64. What is the ratio of the CO2 emissions (% of total fuel combustion) of 1960 in Italy to that in New Zealand?
Provide a short and direct response. 0.72. What is the ratio of the CO2 emissions (% of total fuel combustion) of 1961 in Italy to that in New Zealand?
Provide a short and direct response. 0.64. What is the ratio of the CO2 emissions (% of total fuel combustion) in 1962 in Italy to that in New Zealand?
Provide a short and direct response. 0.59. What is the ratio of the CO2 emissions (% of total fuel combustion) of 1963 in Italy to that in New Zealand?
Your answer should be very brief. 0.5. What is the ratio of the CO2 emissions (% of total fuel combustion) in 1960 in Japan to that in Luxembourg?
Offer a terse response. 14.93. What is the ratio of the CO2 emissions (% of total fuel combustion) in 1961 in Japan to that in Luxembourg?
Offer a very short reply. 23.95. What is the ratio of the CO2 emissions (% of total fuel combustion) of 1962 in Japan to that in Luxembourg?
Keep it short and to the point. 17.85. What is the ratio of the CO2 emissions (% of total fuel combustion) of 1963 in Japan to that in Luxembourg?
Provide a short and direct response. 25.57. What is the ratio of the CO2 emissions (% of total fuel combustion) of 1960 in Japan to that in Netherlands?
Provide a short and direct response. 0.46. What is the ratio of the CO2 emissions (% of total fuel combustion) in 1961 in Japan to that in Netherlands?
Your answer should be very brief. 0.52. What is the ratio of the CO2 emissions (% of total fuel combustion) of 1962 in Japan to that in Netherlands?
Keep it short and to the point. 0.59. What is the ratio of the CO2 emissions (% of total fuel combustion) in 1963 in Japan to that in Netherlands?
Provide a succinct answer. 0.74. What is the ratio of the CO2 emissions (% of total fuel combustion) of 1960 in Japan to that in New Zealand?
Your response must be concise. 0.48. What is the ratio of the CO2 emissions (% of total fuel combustion) of 1961 in Japan to that in New Zealand?
Offer a very short reply. 0.49. What is the ratio of the CO2 emissions (% of total fuel combustion) of 1962 in Japan to that in New Zealand?
Give a very brief answer. 0.54. What is the ratio of the CO2 emissions (% of total fuel combustion) of 1963 in Japan to that in New Zealand?
Provide a succinct answer. 0.57. What is the ratio of the CO2 emissions (% of total fuel combustion) of 1960 in Luxembourg to that in Netherlands?
Your response must be concise. 0.03. What is the ratio of the CO2 emissions (% of total fuel combustion) of 1961 in Luxembourg to that in Netherlands?
Keep it short and to the point. 0.02. What is the ratio of the CO2 emissions (% of total fuel combustion) of 1962 in Luxembourg to that in Netherlands?
Make the answer very short. 0.03. What is the ratio of the CO2 emissions (% of total fuel combustion) in 1963 in Luxembourg to that in Netherlands?
Provide a succinct answer. 0.03. What is the ratio of the CO2 emissions (% of total fuel combustion) in 1960 in Luxembourg to that in New Zealand?
Provide a succinct answer. 0.03. What is the ratio of the CO2 emissions (% of total fuel combustion) of 1961 in Luxembourg to that in New Zealand?
Make the answer very short. 0.02. What is the ratio of the CO2 emissions (% of total fuel combustion) of 1962 in Luxembourg to that in New Zealand?
Your answer should be compact. 0.03. What is the ratio of the CO2 emissions (% of total fuel combustion) in 1963 in Luxembourg to that in New Zealand?
Provide a succinct answer. 0.02. What is the ratio of the CO2 emissions (% of total fuel combustion) in 1960 in Netherlands to that in New Zealand?
Ensure brevity in your answer.  1.05. What is the ratio of the CO2 emissions (% of total fuel combustion) of 1961 in Netherlands to that in New Zealand?
Ensure brevity in your answer.  0.94. What is the ratio of the CO2 emissions (% of total fuel combustion) in 1962 in Netherlands to that in New Zealand?
Your response must be concise. 0.91. What is the ratio of the CO2 emissions (% of total fuel combustion) of 1963 in Netherlands to that in New Zealand?
Provide a succinct answer. 0.78. What is the difference between the highest and the second highest CO2 emissions (% of total fuel combustion) of 1960?
Provide a short and direct response. 0.26. What is the difference between the highest and the second highest CO2 emissions (% of total fuel combustion) in 1961?
Keep it short and to the point. 0.34. What is the difference between the highest and the second highest CO2 emissions (% of total fuel combustion) of 1962?
Keep it short and to the point. 0.52. What is the difference between the highest and the second highest CO2 emissions (% of total fuel combustion) of 1963?
Your answer should be compact. 1.33. What is the difference between the highest and the lowest CO2 emissions (% of total fuel combustion) in 1960?
Make the answer very short. 5.53. What is the difference between the highest and the lowest CO2 emissions (% of total fuel combustion) in 1961?
Ensure brevity in your answer.  5.54. What is the difference between the highest and the lowest CO2 emissions (% of total fuel combustion) of 1962?
Your answer should be compact. 5.72. What is the difference between the highest and the lowest CO2 emissions (% of total fuel combustion) in 1963?
Provide a succinct answer. 5.79. 